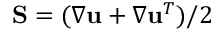<formula> <loc_0><loc_0><loc_500><loc_500>S = ( \nabla u + \nabla u ^ { T } ) / 2</formula> 